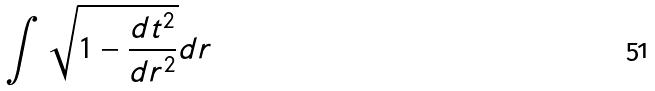<formula> <loc_0><loc_0><loc_500><loc_500>\int \sqrt { 1 - \frac { d t ^ { 2 } } { d r ^ { 2 } } } d r</formula> 